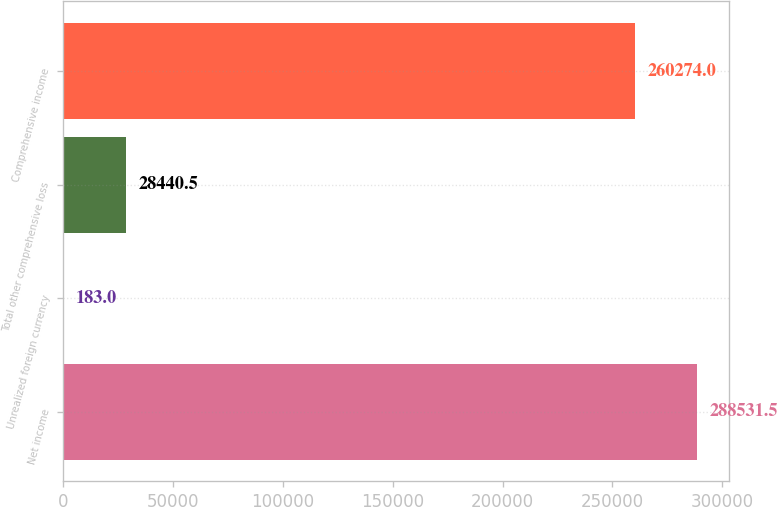Convert chart to OTSL. <chart><loc_0><loc_0><loc_500><loc_500><bar_chart><fcel>Net income<fcel>Unrealized foreign currency<fcel>Total other comprehensive loss<fcel>Comprehensive income<nl><fcel>288532<fcel>183<fcel>28440.5<fcel>260274<nl></chart> 